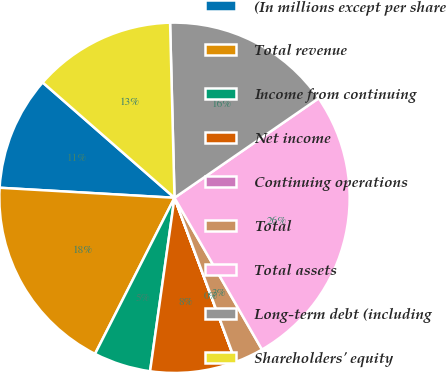Convert chart to OTSL. <chart><loc_0><loc_0><loc_500><loc_500><pie_chart><fcel>(In millions except per share<fcel>Total revenue<fcel>Income from continuing<fcel>Net income<fcel>Continuing operations<fcel>Total<fcel>Total assets<fcel>Long-term debt (including<fcel>Shareholders' equity<nl><fcel>10.53%<fcel>18.42%<fcel>5.27%<fcel>7.9%<fcel>0.01%<fcel>2.64%<fcel>26.3%<fcel>15.79%<fcel>13.16%<nl></chart> 